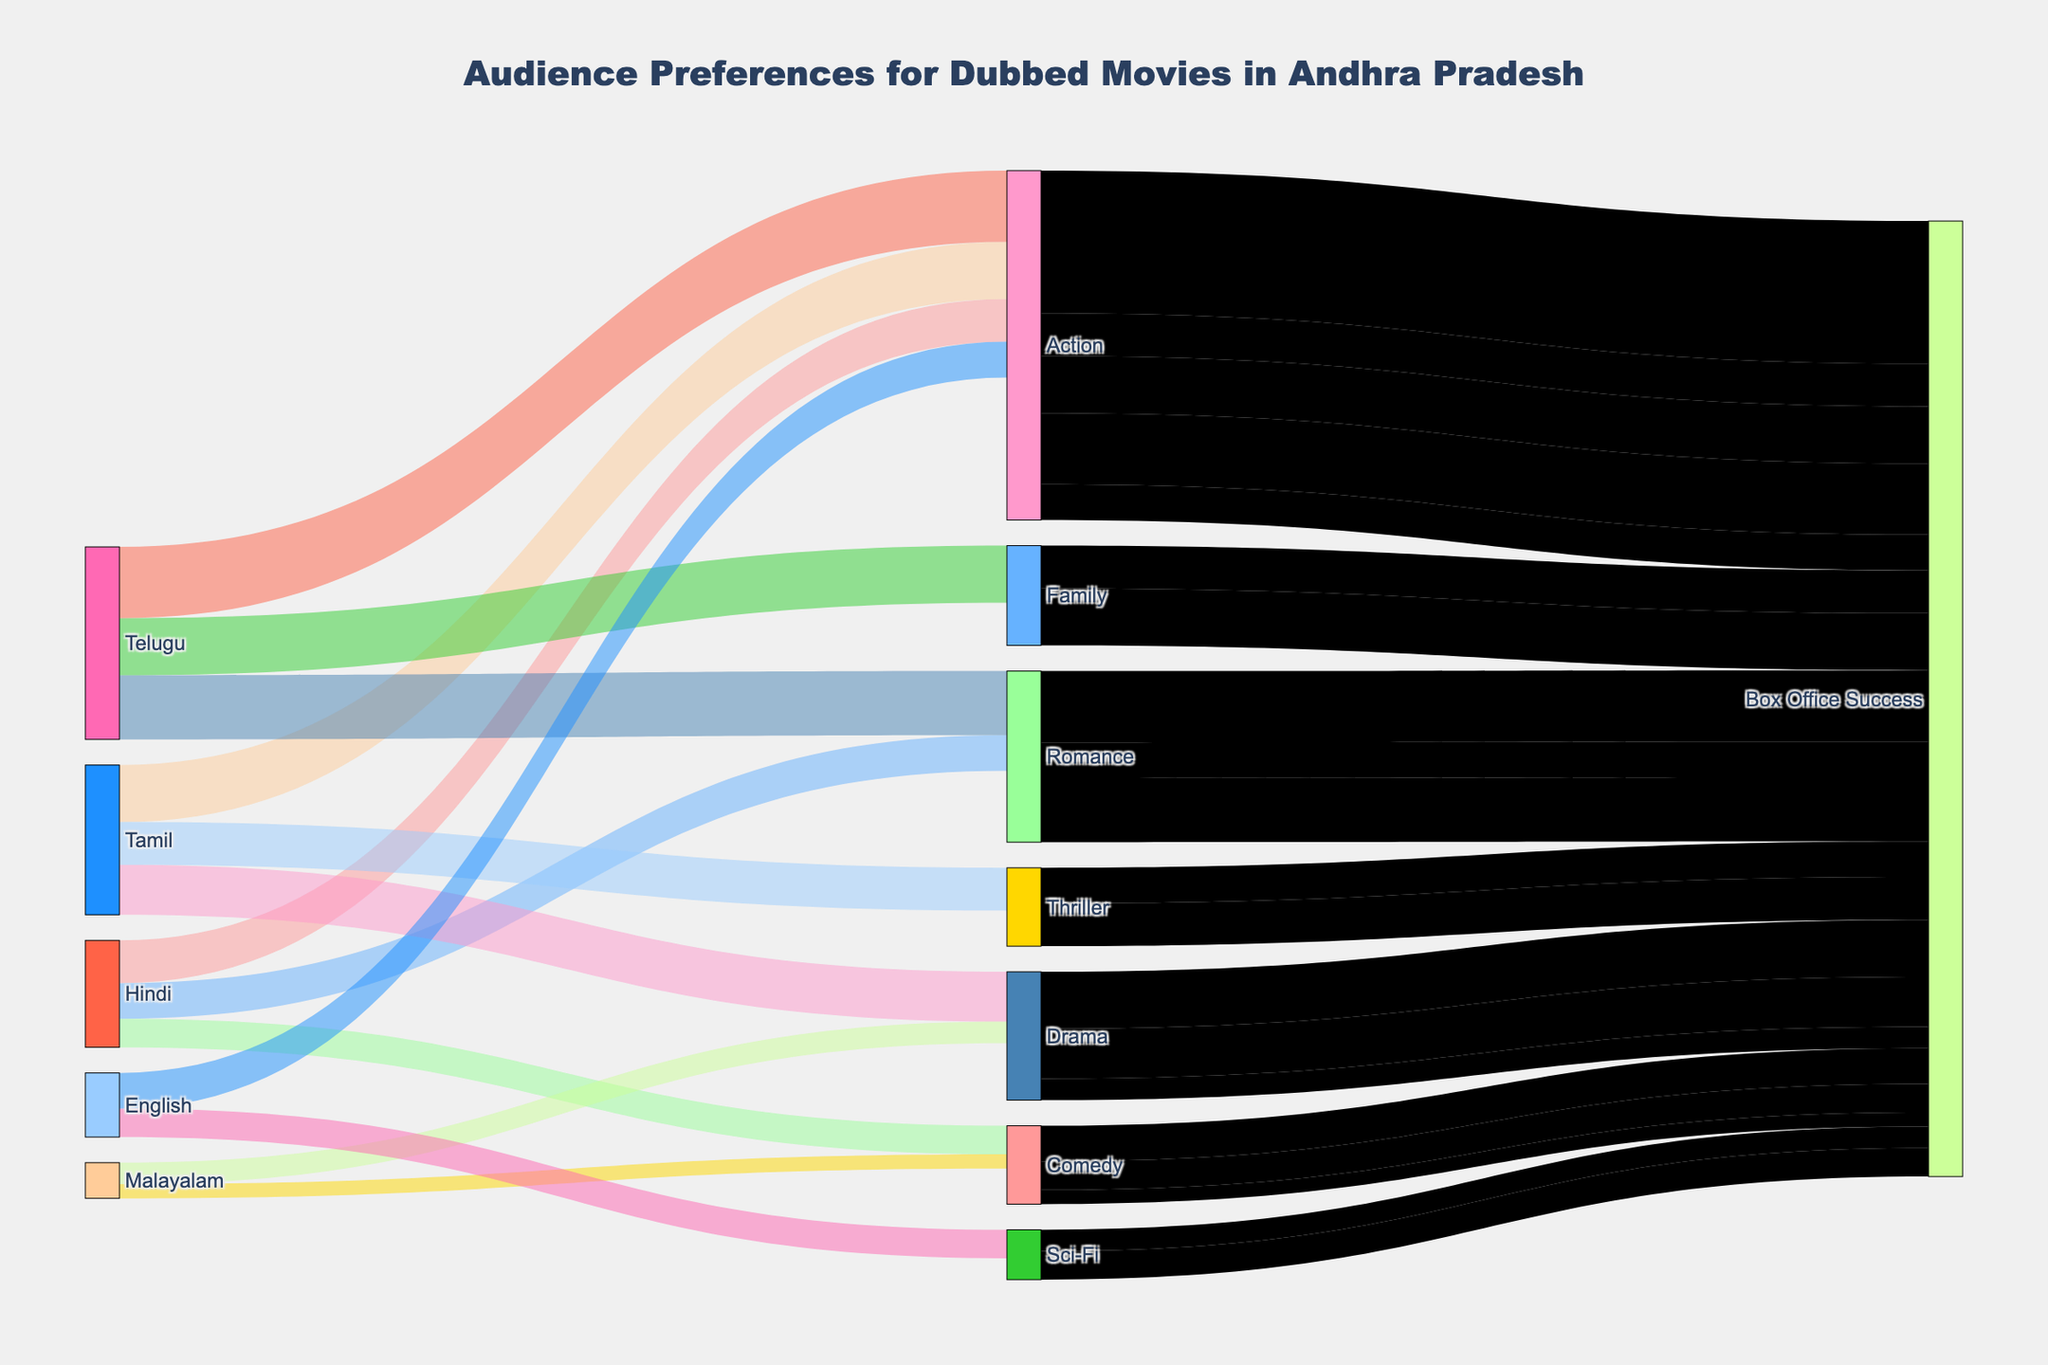Which genre has the highest audience preference for dubbed movies in Telugu? Find the weights for Telugu in the diagram, then look for the highest weight among genres connected to Telugu.
Answer: Action What is the total audience preference for dubbed movies originally in Hindi? Sum the weights of all genres connected to Hindi. 30000 (Action) + 25000 (Romance) + 20000 (Comedy).
Answer: 75000 How does the audience preference for Action movies differ between Telugu and Hindi? Compare the weights of Action in Telugu and Hindi. Telugu Action: 50000, Hindi Action: 30000.
Answer: Telugu has 20000 more preference weight Which genre contributes least to the Box Office Success for Malayalam dubbed movies? Check the weights for genres connected to Malayalam and find the smallest weight.
Answer: Comedy with 10000 How many genres in total are associated with Box Office Success? Count the unique genres connected to Box Office Success from the diagram.
Answer: 6 What's the combined audience preference for Thriller and Sci-Fi movies from all languages? Sum the weights for Thriller and Sci-Fi from the diagram. Thriller: 30000, Sci-Fi: 20000.
Answer: 50000 If English movies' total audience preference weight is compared to Hindi movies, which one is higher? Sum the weights of all genres connected to English and Hindi respectively, then compare. English: 20000 (Sci-Fi) + 25000 (Action) = 45000, Hindi: 30000 (Action) + 25000 (Romance) + 20000 (Comedy) = 75000.
Answer: Hindi has a higher preference weight Which genre has an equal connection both to Telugu and Hindi? Check the genres that have equal weights connected to both Telugu and Hindi.
Answer: None What's the total audience preference for all Action movies across different languages? Sum all the weights connected to the Action genre from all languages. Hindi: 30000, Telugu: 50000, Tamil: 40000, English: 25000.
Answer: 145000 Which genre has the highest audience preference weight directly contributing to Box Office Success? Find the genre with the highest weight that directly connects to Box Office Success.
Answer: Action 